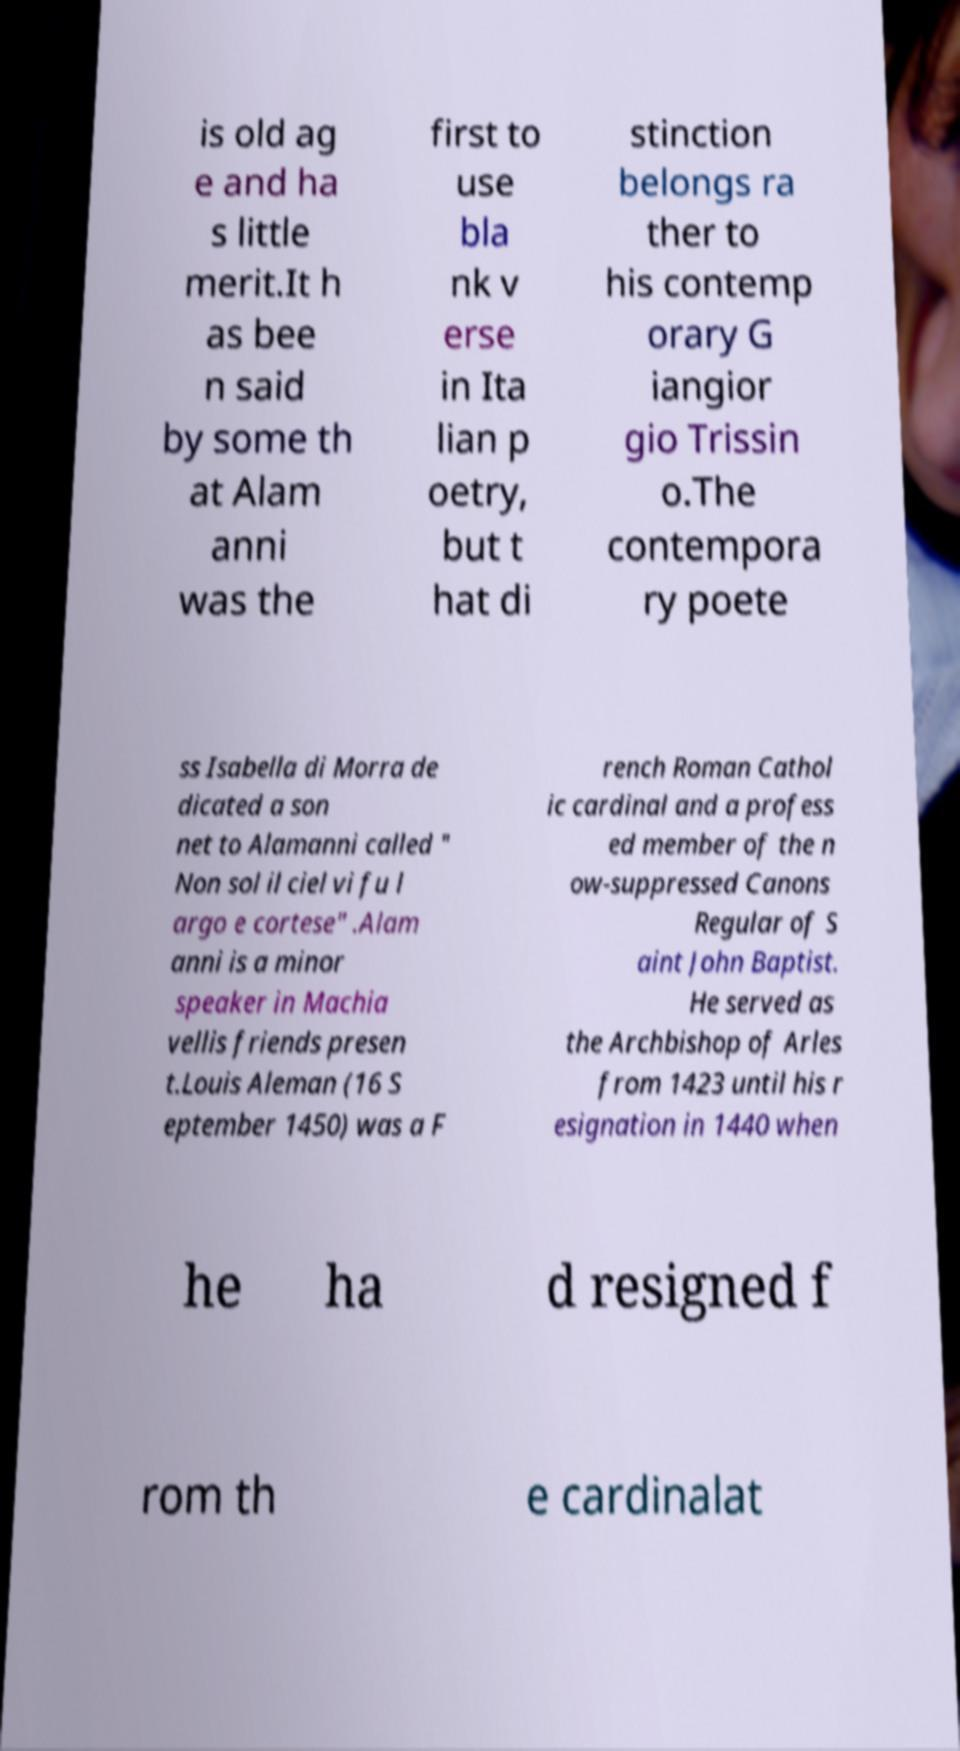I need the written content from this picture converted into text. Can you do that? is old ag e and ha s little merit.It h as bee n said by some th at Alam anni was the first to use bla nk v erse in Ita lian p oetry, but t hat di stinction belongs ra ther to his contemp orary G iangior gio Trissin o.The contempora ry poete ss Isabella di Morra de dicated a son net to Alamanni called " Non sol il ciel vi fu l argo e cortese" .Alam anni is a minor speaker in Machia vellis friends presen t.Louis Aleman (16 S eptember 1450) was a F rench Roman Cathol ic cardinal and a profess ed member of the n ow-suppressed Canons Regular of S aint John Baptist. He served as the Archbishop of Arles from 1423 until his r esignation in 1440 when he ha d resigned f rom th e cardinalat 